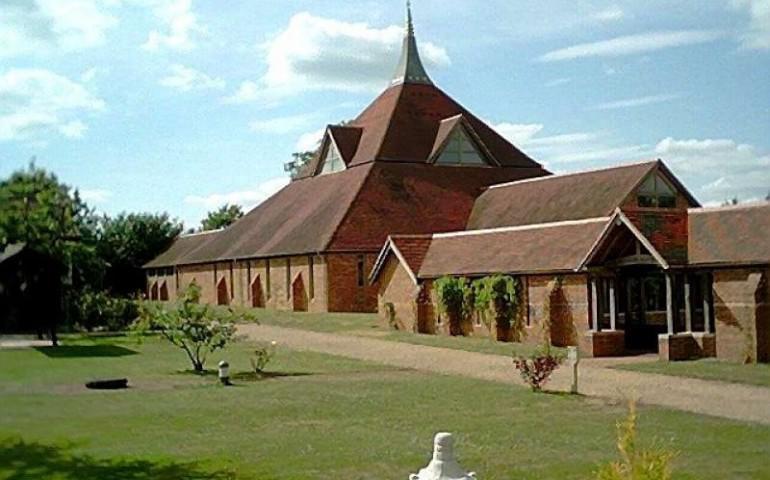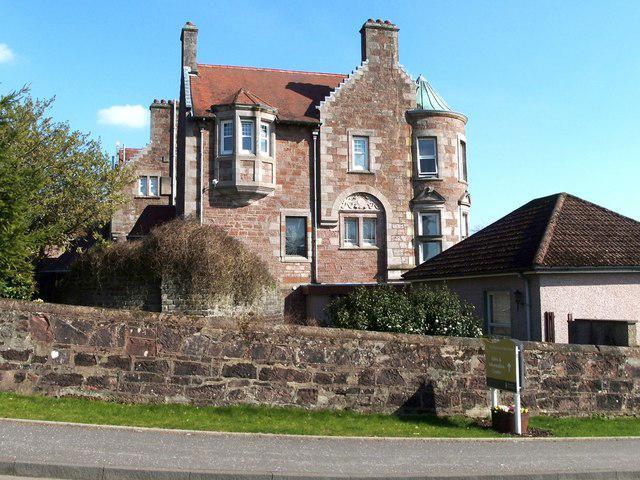The first image is the image on the left, the second image is the image on the right. For the images shown, is this caption "There is no visible grass in at least one image." true? Answer yes or no. No. 